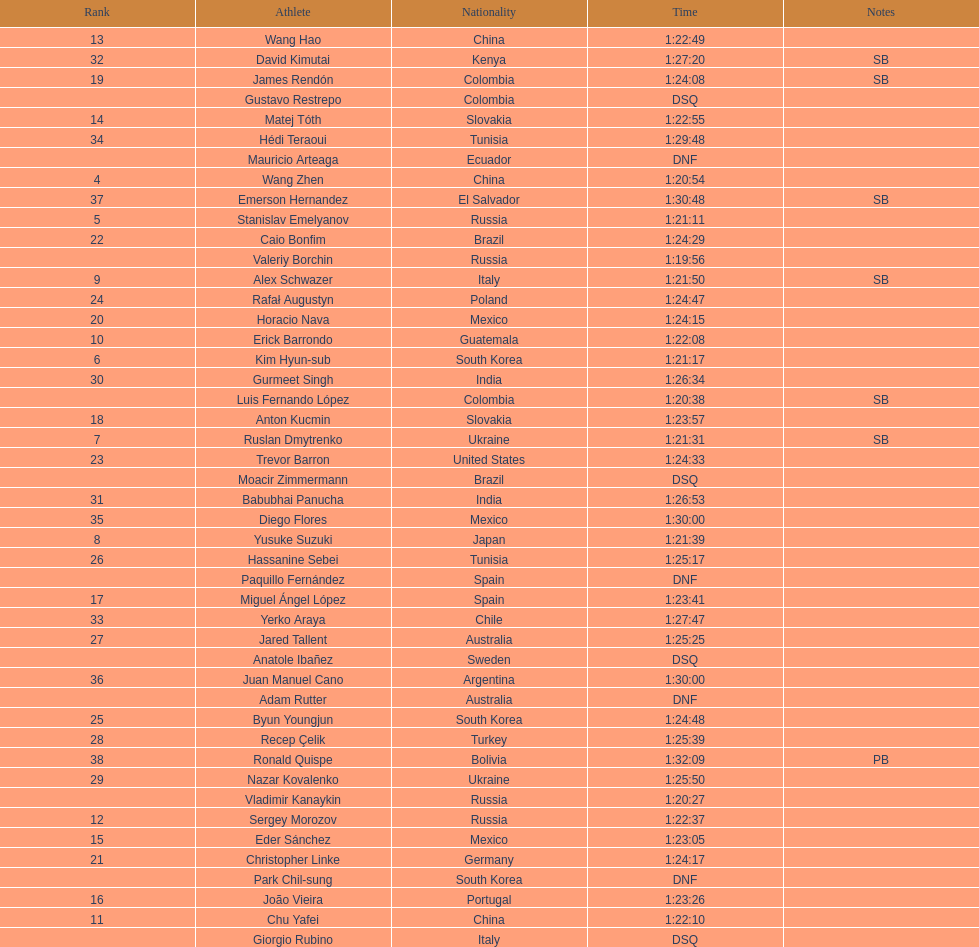Wang zhen and wang hao were both from which country? China. 